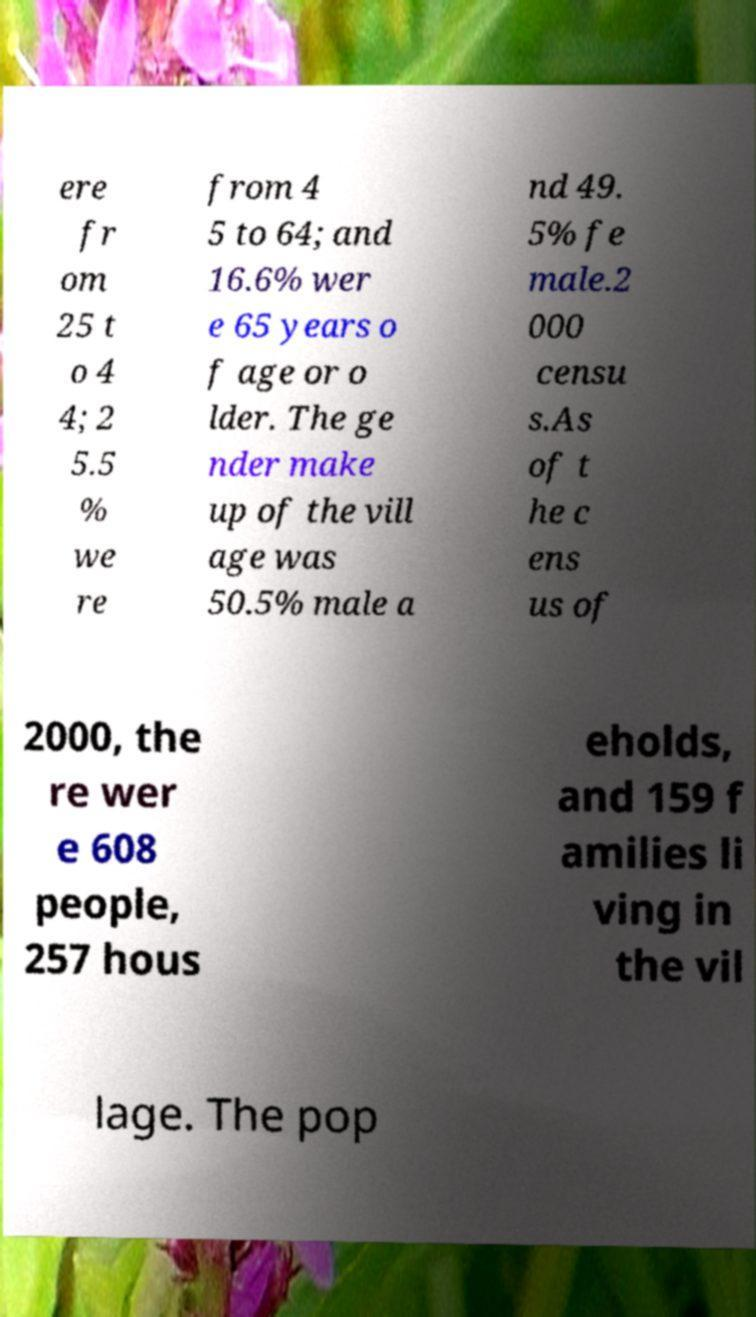I need the written content from this picture converted into text. Can you do that? ere fr om 25 t o 4 4; 2 5.5 % we re from 4 5 to 64; and 16.6% wer e 65 years o f age or o lder. The ge nder make up of the vill age was 50.5% male a nd 49. 5% fe male.2 000 censu s.As of t he c ens us of 2000, the re wer e 608 people, 257 hous eholds, and 159 f amilies li ving in the vil lage. The pop 